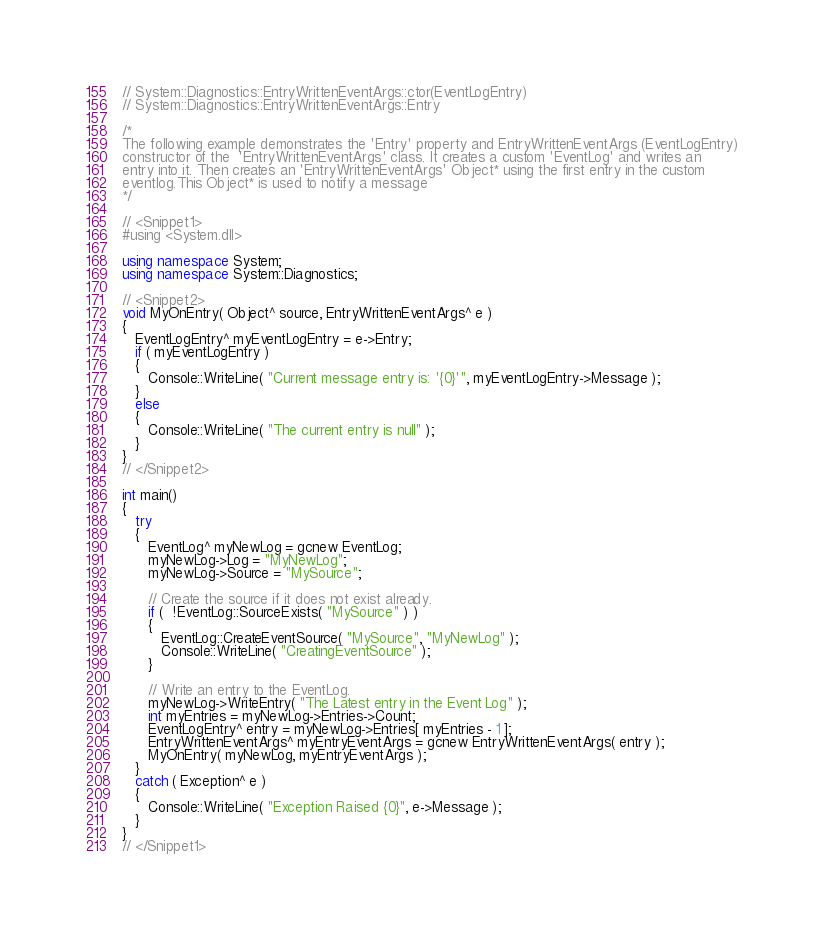Convert code to text. <code><loc_0><loc_0><loc_500><loc_500><_C++_>// System::Diagnostics::EntryWrittenEventArgs::ctor(EventLogEntry)
// System::Diagnostics::EntryWrittenEventArgs::Entry

/* 
The following example demonstrates the 'Entry' property and EntryWrittenEventArgs (EventLogEntry)
constructor of the  'EntryWrittenEventArgs' class. It creates a custom 'EventLog' and writes an
entry into it. Then creates an 'EntryWrittenEventArgs' Object* using the first entry in the custom
eventlog.This Object* is used to notify a message 
*/

// <Snippet1>
#using <System.dll>

using namespace System;
using namespace System::Diagnostics;

// <Snippet2>
void MyOnEntry( Object^ source, EntryWrittenEventArgs^ e )
{
   EventLogEntry^ myEventLogEntry = e->Entry;
   if ( myEventLogEntry )
   {
      Console::WriteLine( "Current message entry is: '{0}'", myEventLogEntry->Message );
   }
   else
   {
      Console::WriteLine( "The current entry is null" );
   }
}
// </Snippet2>

int main()
{
   try
   {
      EventLog^ myNewLog = gcnew EventLog;
      myNewLog->Log = "MyNewLog";
      myNewLog->Source = "MySource";
      
      // Create the source if it does not exist already.
      if (  !EventLog::SourceExists( "MySource" ) )
      {
         EventLog::CreateEventSource( "MySource", "MyNewLog" );
         Console::WriteLine( "CreatingEventSource" );
      }
      
      // Write an entry to the EventLog.
      myNewLog->WriteEntry( "The Latest entry in the Event Log" );
      int myEntries = myNewLog->Entries->Count;
      EventLogEntry^ entry = myNewLog->Entries[ myEntries - 1 ];
      EntryWrittenEventArgs^ myEntryEventArgs = gcnew EntryWrittenEventArgs( entry );
      MyOnEntry( myNewLog, myEntryEventArgs );
   }
   catch ( Exception^ e ) 
   {
      Console::WriteLine( "Exception Raised {0}", e->Message );
   }
}
// </Snippet1>
</code> 